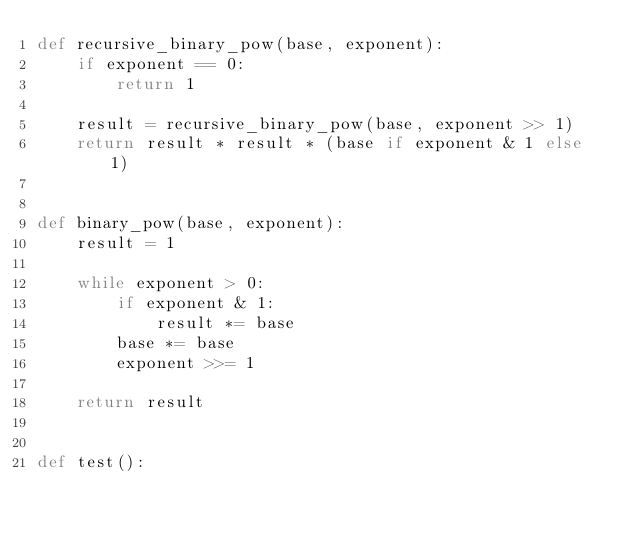<code> <loc_0><loc_0><loc_500><loc_500><_Python_>def recursive_binary_pow(base, exponent):
    if exponent == 0:
        return 1

    result = recursive_binary_pow(base, exponent >> 1)
    return result * result * (base if exponent & 1 else 1)


def binary_pow(base, exponent):
    result = 1

    while exponent > 0:
        if exponent & 1:
            result *= base
        base *= base
        exponent >>= 1

    return result


def test():</code> 